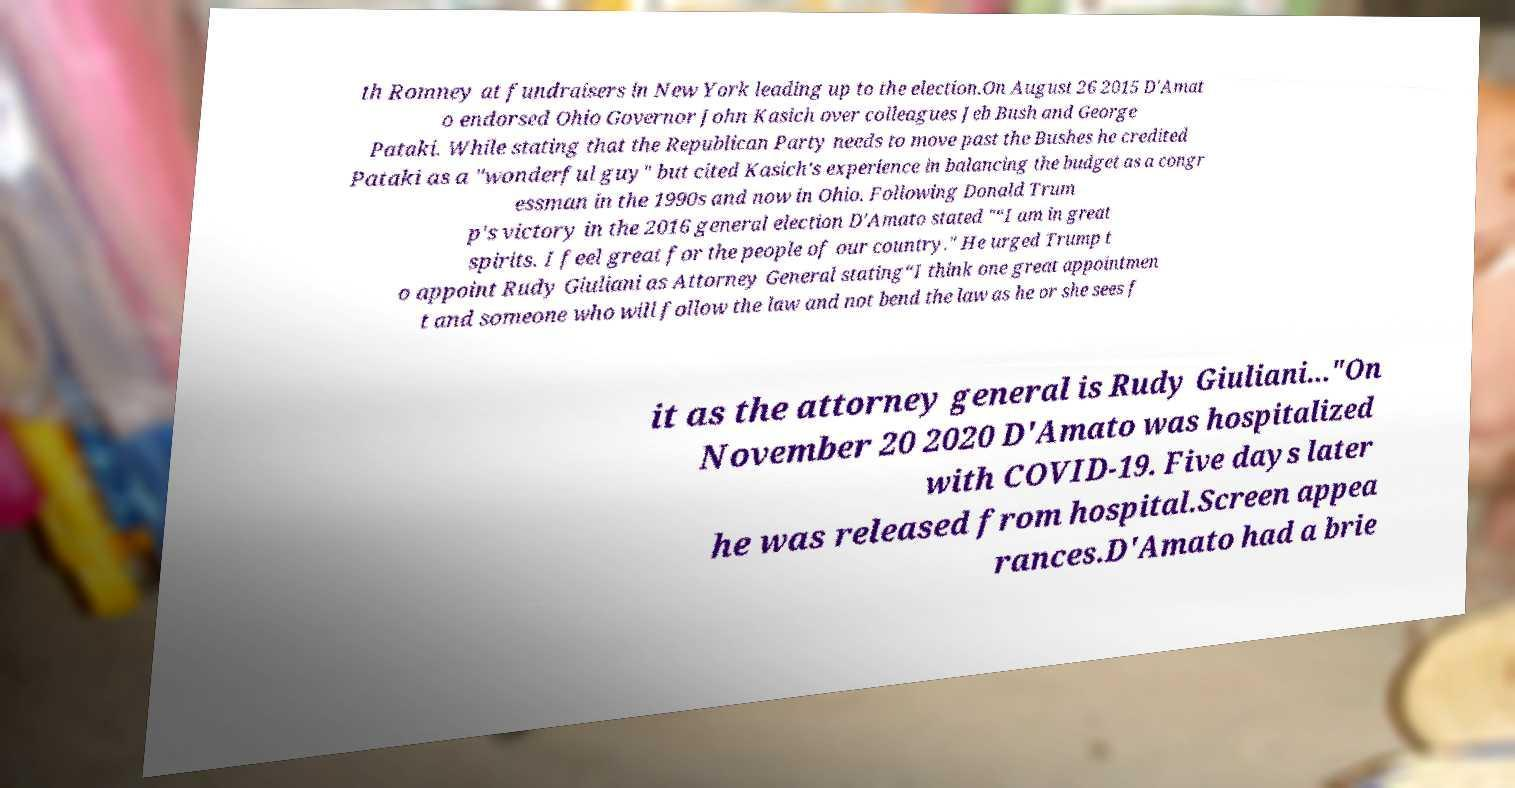Please identify and transcribe the text found in this image. th Romney at fundraisers in New York leading up to the election.On August 26 2015 D'Amat o endorsed Ohio Governor John Kasich over colleagues Jeb Bush and George Pataki. While stating that the Republican Party needs to move past the Bushes he credited Pataki as a "wonderful guy" but cited Kasich's experience in balancing the budget as a congr essman in the 1990s and now in Ohio. Following Donald Trum p's victory in the 2016 general election D'Amato stated "“I am in great spirits. I feel great for the people of our country." He urged Trump t o appoint Rudy Giuliani as Attorney General stating“I think one great appointmen t and someone who will follow the law and not bend the law as he or she sees f it as the attorney general is Rudy Giuliani..."On November 20 2020 D'Amato was hospitalized with COVID-19. Five days later he was released from hospital.Screen appea rances.D'Amato had a brie 